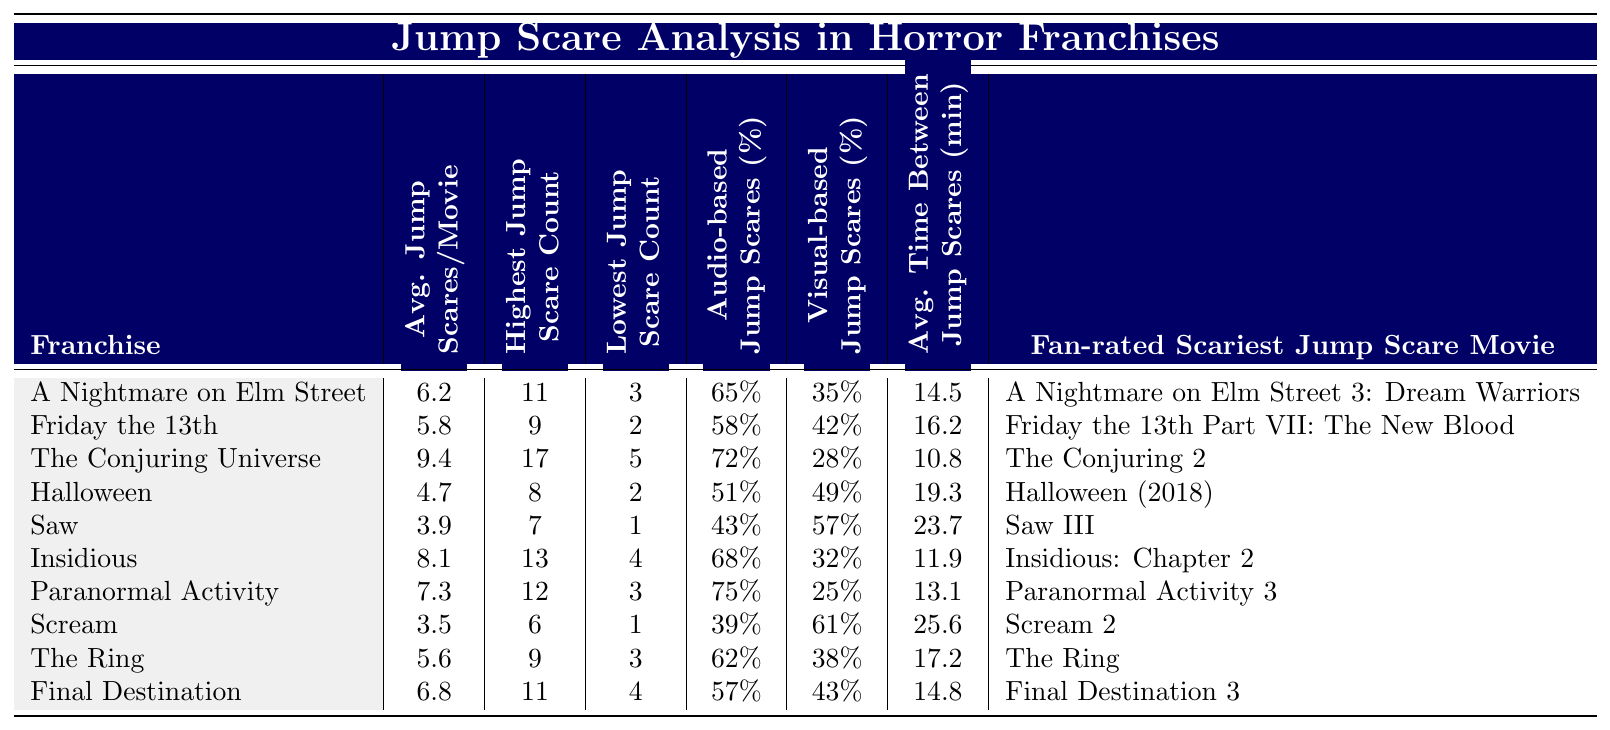What horror franchise has the highest average jump scares per movie? The table lists the average jump scares per movie for each franchise. By comparing the values, "The Conjuring Universe" has the highest average at 9.4.
Answer: The Conjuring Universe Which franchise has the lowest jump scare count? The table shows the lowest jump scare count for each franchise. "Saw" has the lowest count of 1.
Answer: Saw What is the percentage of audio-based jump scares in "Paranormal Activity"? The table provides the percentage of audio-based jump scares for "Paranormal Activity" as 75%.
Answer: 75% Find the difference in average time between jump scares for "Scream" and "Insidious." The average time between jump scares for "Scream" is 25.6 minutes, and for "Insidious," it is 11.9 minutes. The difference is 25.6 - 11.9 = 13.7 minutes.
Answer: 13.7 minutes Is "Halloween" above or below the average jump scares per movie for the entire table? The average jump scares for "Halloween" is 4.7. The average of all franchises can be calculated, but by checking values, 4.7 is less than the computed average of about 6.4.
Answer: Below Which franchise has the highest percentage of visual-based jump scares? By analyzing the percentage of visual-based jump scares for each franchise, "Scream" has the highest percentage at 61%.
Answer: Scream What is the average jump scares for the franchise "Final Destination"? The table indicates "Final Destination" has an average jump scare count of 6.8.
Answer: 6.8 If we consider the "fan rated scariest jump scare movie," which franchise corresponds to "Insidious: Chapter 2"? The franchise associated with "Insidious: Chapter 2" is "Insidious."
Answer: Insidious Calculate the total jump scare count for the highest jump scare movies of "A Nightmare on Elm Street," "Friday the 13th," and "The Ring." From the table, the highest counts are 11, 9, and 9 respectively. Adding these gives 11 + 9 + 9 = 29 total jump scares.
Answer: 29 Which franchise has the least percentage of audio-based jump scares? The franchise with the lowest percentage of audio-based jump scares is "Saw," with 43%.
Answer: Saw 